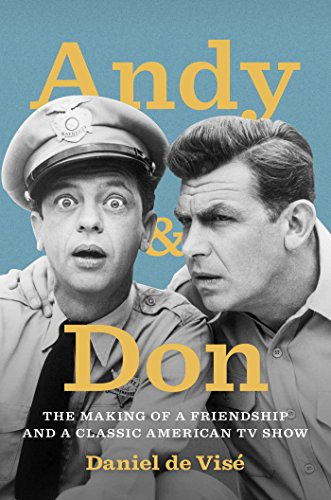Can you describe the visual style and aesthetic of the cover art? The cover art features a vintage and nostalgic aesthetic, emphasizing the classic nature of the TV show it discusses. The monochrome photograph underscores the period when the show was popular, and the expressive poses of the characters convey the humor and the dynamics of their on-screen partnership. 